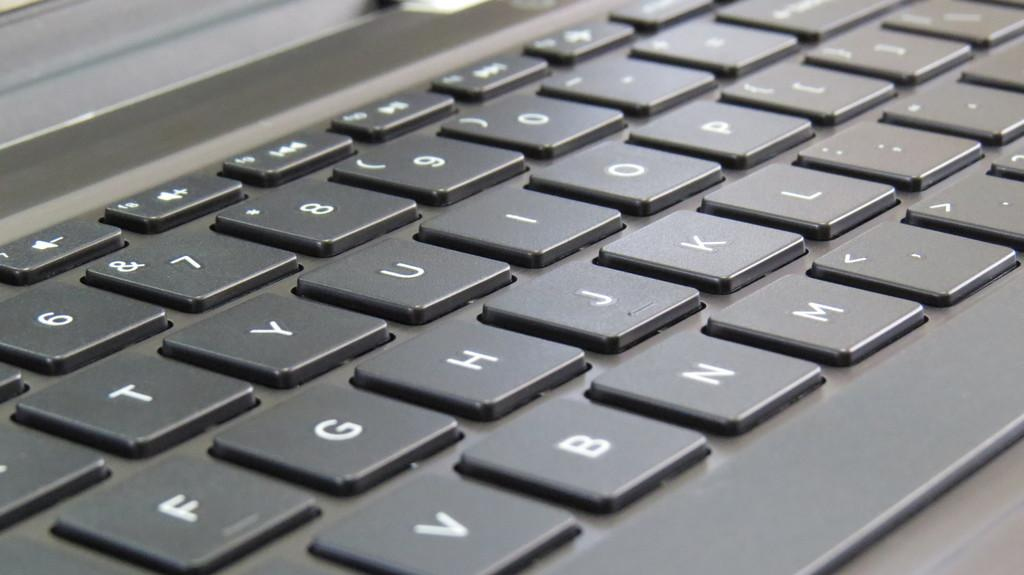<image>
Give a short and clear explanation of the subsequent image. Black laptop with the key B between the keys V and N. 